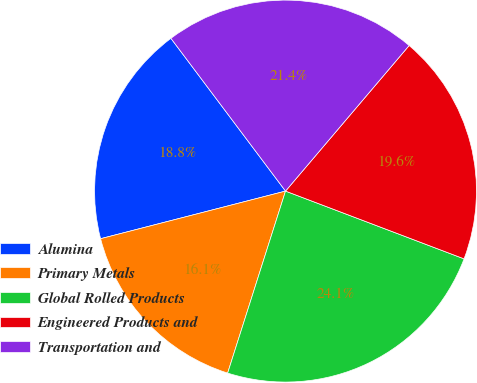Convert chart to OTSL. <chart><loc_0><loc_0><loc_500><loc_500><pie_chart><fcel>Alumina<fcel>Primary Metals<fcel>Global Rolled Products<fcel>Engineered Products and<fcel>Transportation and<nl><fcel>18.77%<fcel>16.09%<fcel>24.13%<fcel>19.57%<fcel>21.45%<nl></chart> 